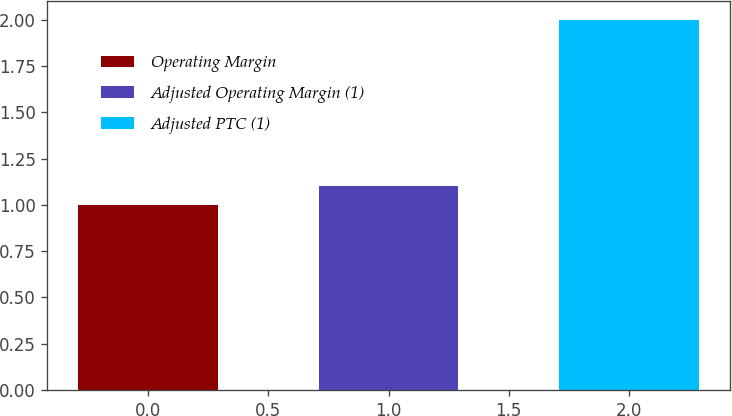<chart> <loc_0><loc_0><loc_500><loc_500><bar_chart><fcel>Operating Margin<fcel>Adjusted Operating Margin (1)<fcel>Adjusted PTC (1)<nl><fcel>1<fcel>1.1<fcel>2<nl></chart> 